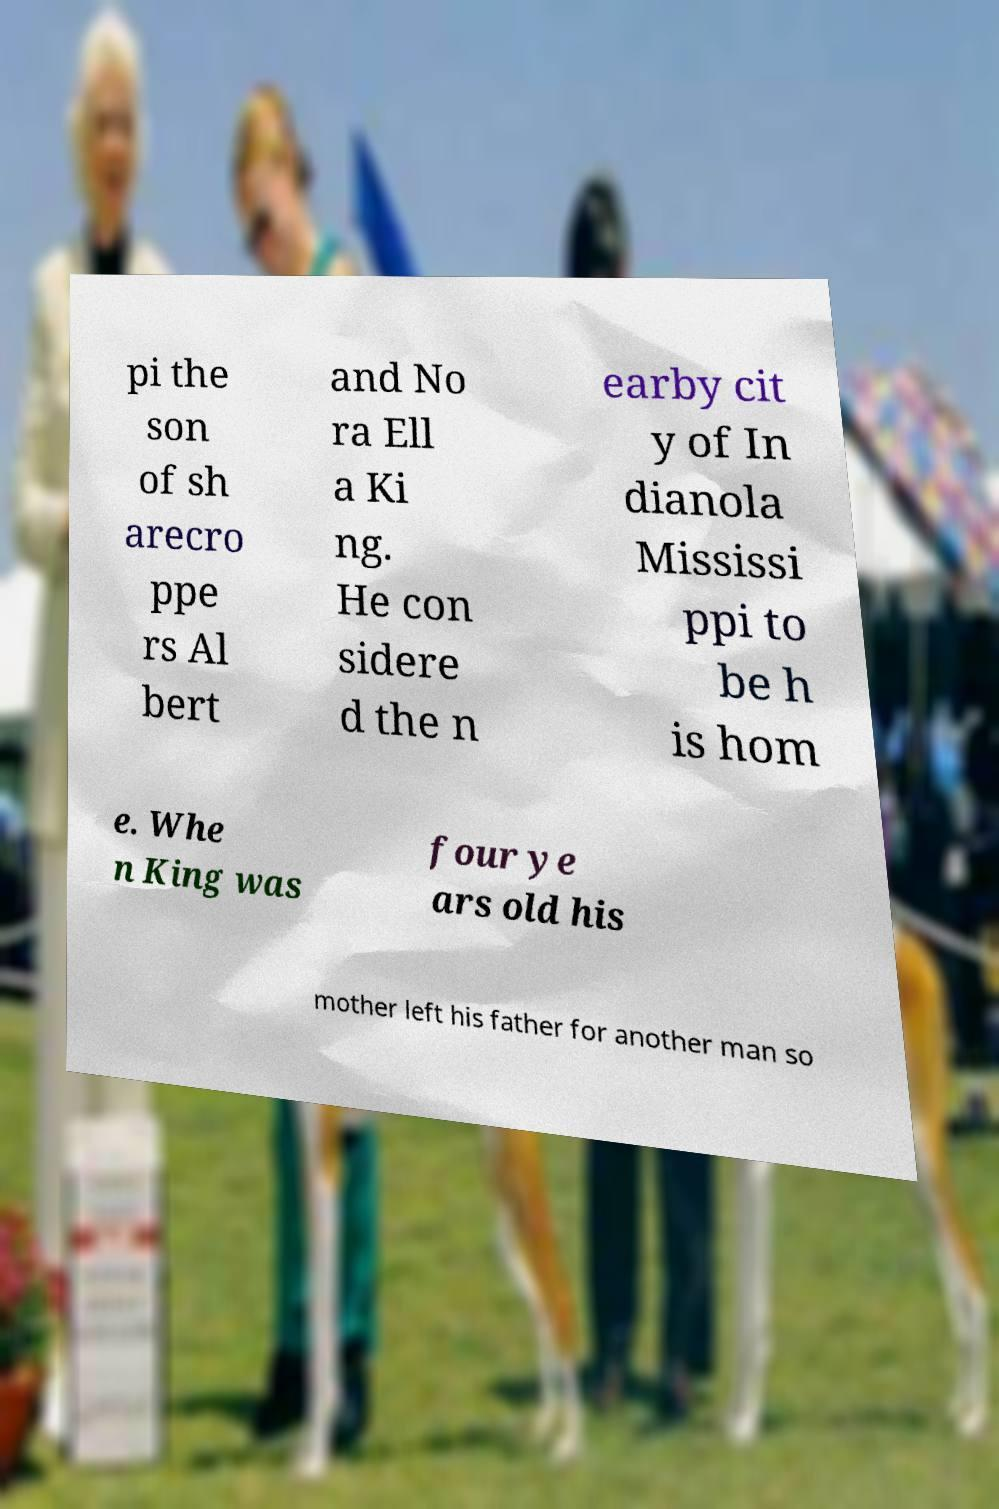Can you accurately transcribe the text from the provided image for me? pi the son of sh arecro ppe rs Al bert and No ra Ell a Ki ng. He con sidere d the n earby cit y of In dianola Mississi ppi to be h is hom e. Whe n King was four ye ars old his mother left his father for another man so 